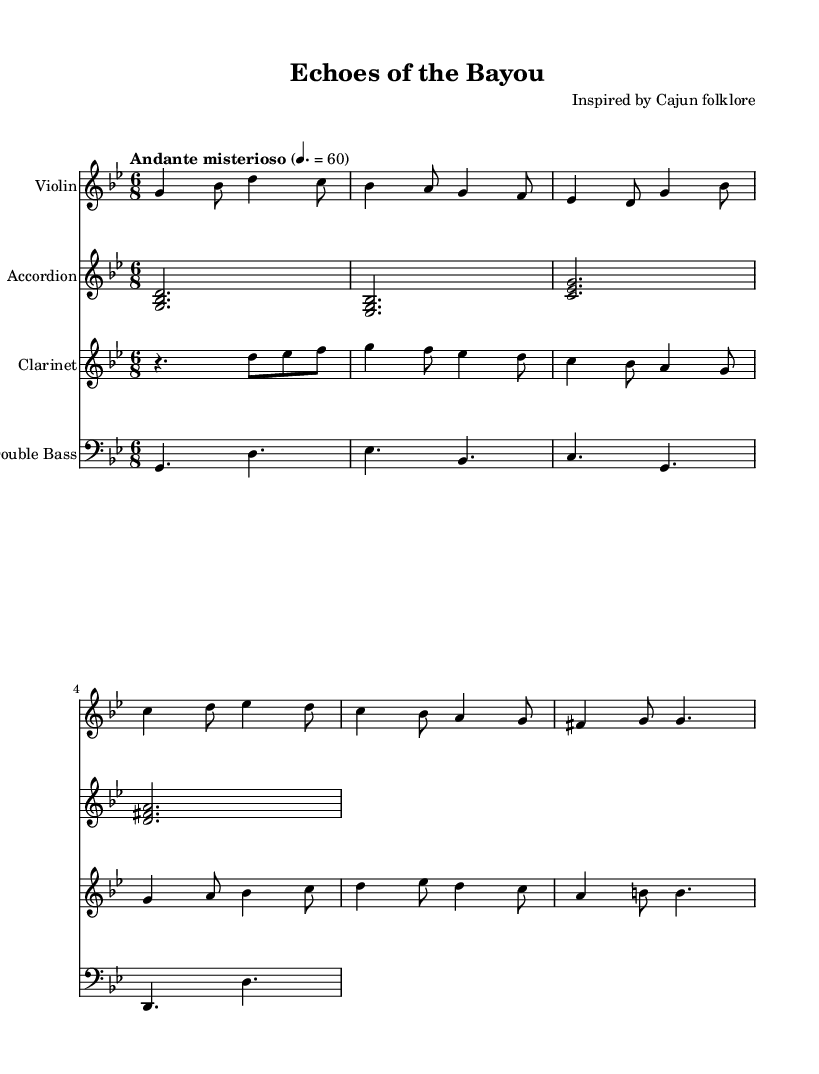What is the key signature of this music? The key signature is indicated in the global section of the score and shows 2 flats, which correspond to B-flat and E-flat. This means the music is in G minor.
Answer: G minor What is the time signature of this music? The time signature is specified in the global section and shows a 6 over 8, meaning there are six eighth notes per measure.
Answer: 6/8 What is the tempo marking for this piece? The tempo marking in the global section indicates "Andante misterioso," which suggests a moderate tempo, typically around 60 beats per minute.
Answer: Andante misterioso How many instruments are featured in this composition? The score lists four different staves, each representing a distinct instrument: Violin, Accordion, Clarinet, and Double Bass. Therefore, there are four instruments in total.
Answer: Four Which folk culture is this composition inspired by? The header provides the context for the composition, stating that it is inspired by Cajun folklore, which is associated with the culture of Louisiana.
Answer: Cajun folklore What is the first note played by the violin? The first note in the violin part is G, as indicated at the beginning of the music.
Answer: G What dynamic marking can be inferred from the tempo indication? The tempo marking "Andante misterioso" implies a mysterious and calm character, typically associated with soft dynamics, although specific dynamic markings are not shown.
Answer: Soft 